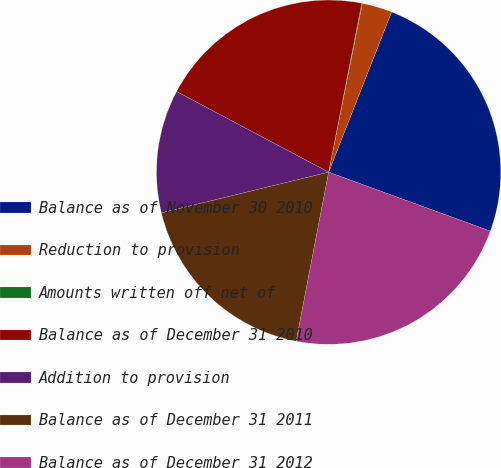Convert chart. <chart><loc_0><loc_0><loc_500><loc_500><pie_chart><fcel>Balance as of November 30 2010<fcel>Reduction to provision<fcel>Amounts written off net of<fcel>Balance as of December 31 2010<fcel>Addition to provision<fcel>Balance as of December 31 2011<fcel>Balance as of December 31 2012<nl><fcel>24.6%<fcel>2.82%<fcel>0.06%<fcel>20.32%<fcel>11.56%<fcel>18.18%<fcel>22.46%<nl></chart> 